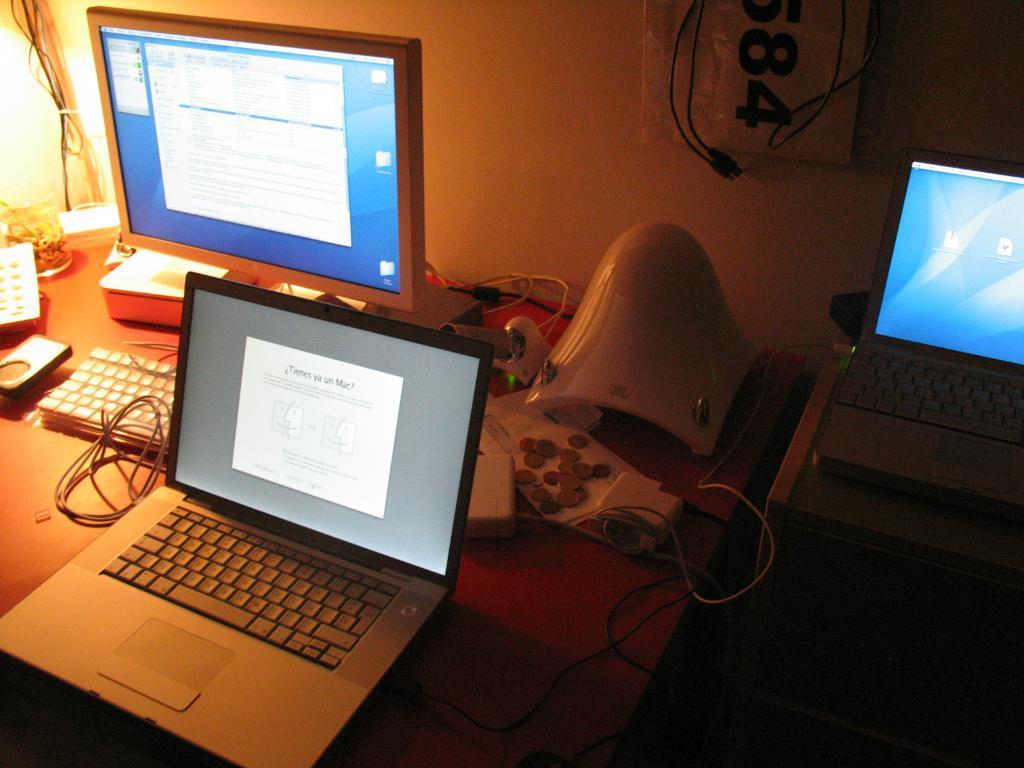Could you give a brief overview of what you see in this image? This is a wooden table where a computer with keyboard, a laptop and electrical extension box are kept on it. We can observe a laptop on the right side as well. 